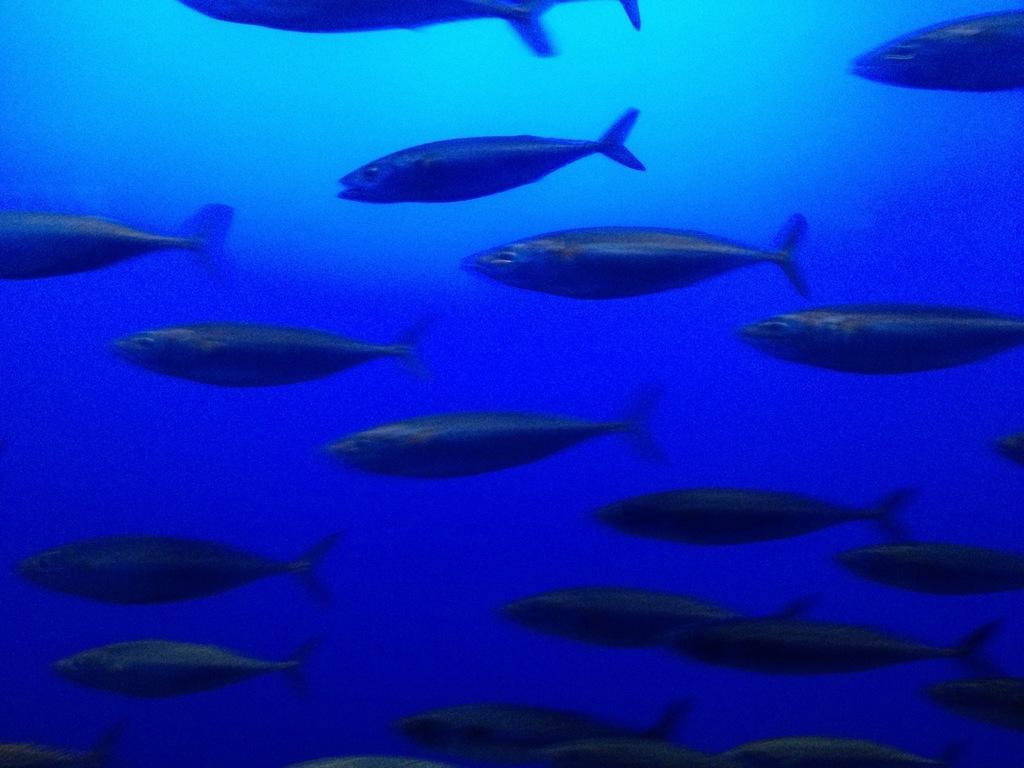Could you give a brief overview of what you see in this image? In this image we can see a group of fishes in the water. 